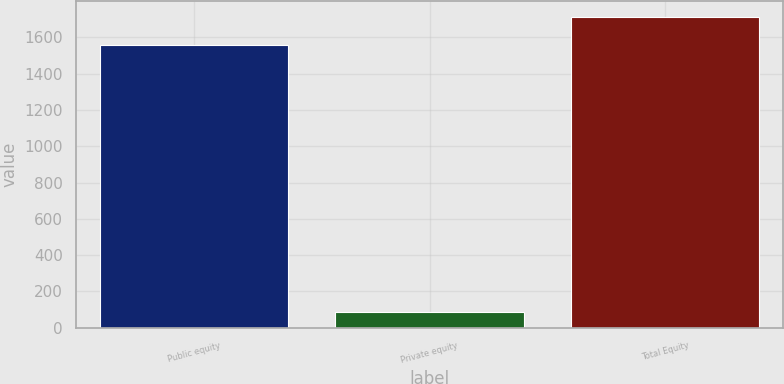<chart> <loc_0><loc_0><loc_500><loc_500><bar_chart><fcel>Public equity<fcel>Private equity<fcel>Total Equity<nl><fcel>1558<fcel>88<fcel>1713.8<nl></chart> 